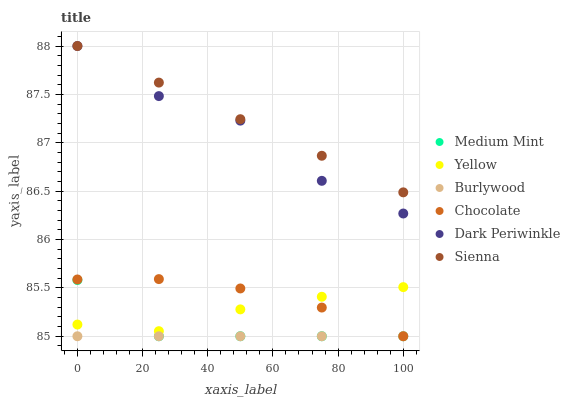Does Burlywood have the minimum area under the curve?
Answer yes or no. Yes. Does Sienna have the maximum area under the curve?
Answer yes or no. Yes. Does Yellow have the minimum area under the curve?
Answer yes or no. No. Does Yellow have the maximum area under the curve?
Answer yes or no. No. Is Burlywood the smoothest?
Answer yes or no. Yes. Is Dark Periwinkle the roughest?
Answer yes or no. Yes. Is Yellow the smoothest?
Answer yes or no. No. Is Yellow the roughest?
Answer yes or no. No. Does Medium Mint have the lowest value?
Answer yes or no. Yes. Does Yellow have the lowest value?
Answer yes or no. No. Does Dark Periwinkle have the highest value?
Answer yes or no. Yes. Does Yellow have the highest value?
Answer yes or no. No. Is Burlywood less than Yellow?
Answer yes or no. Yes. Is Yellow greater than Burlywood?
Answer yes or no. Yes. Does Chocolate intersect Medium Mint?
Answer yes or no. Yes. Is Chocolate less than Medium Mint?
Answer yes or no. No. Is Chocolate greater than Medium Mint?
Answer yes or no. No. Does Burlywood intersect Yellow?
Answer yes or no. No. 